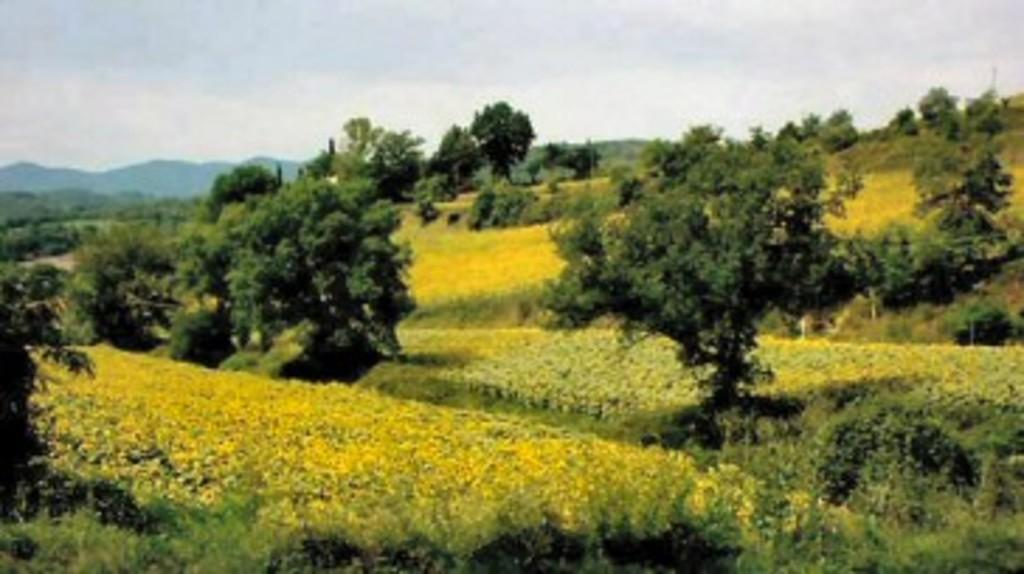What type of landscape is depicted in the image? The image features fields and trees. Are there any natural landmarks visible in the image? Yes, there are mountains in the background of the image. What can be seen in the sky in the image? The sky is visible in the background of the image. What type of iron equipment can be seen in the fields in the image? There is no iron equipment visible in the fields in the image. The fields are described as being covered with vegetation, and no man-made objects are mentioned. 